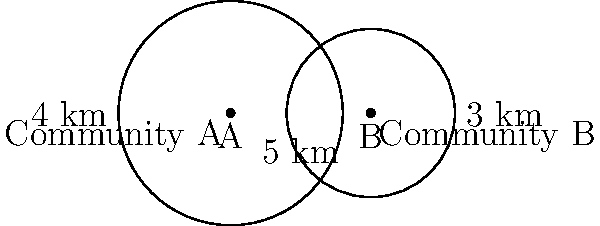Two circular regions represent HIV treatment coverage areas for two different communities. Community A's coverage has a radius of 4 km, while Community B's coverage has a radius of 3 km. The centers of these circles are 5 km apart. Calculate the area of the overlapping region where both communities provide HIV treatment coverage. Round your answer to the nearest square kilometer. To find the area of overlap between two circles, we can use the following steps:

1) First, we need to determine if the circles intersect. They do if the distance between their centers is less than the sum of their radii:
   $5 < 4 + 3 = 7$, so they do intersect.

2) Next, we calculate the distance from each circle's center to the chord of intersection:
   For circle A: $a = \frac{4^2 - 3^2 + 5^2}{2(5)} = 2.9$ km
   For circle B: $b = 5 - 2.9 = 2.1$ km

3) We then find the central angle for each circle:
   For circle A: $\theta_A = 2 \arccos(\frac{2.9}{4}) = 2.2143$ radians
   For circle B: $\theta_B = 2 \arccos(\frac{2.1}{3}) = 2.7127$ radians

4) Now we can calculate the area of each sector:
   Sector A: $\frac{1}{2} \cdot 4^2 \cdot 2.2143 = 8.8572$ km²
   Sector B: $\frac{1}{2} \cdot 3^2 \cdot 2.7127 = 12.2071$ km²

5) We also need to calculate the area of each triangle:
   Triangle A: $\frac{1}{2} \cdot 4 \cdot 2.9 \cdot \sin(2.2143/2) = 5.4101$ km²
   Triangle B: $\frac{1}{2} \cdot 3 \cdot 2.1 \cdot \sin(2.7127/2) = 3.0321$ km²

6) The area of overlap is the sum of the sectors minus the sum of the triangles:
   Overlap = $(8.8572 + 12.2071) - (5.4101 + 3.0321) = 12.6221$ km²

7) Rounding to the nearest square kilometer gives us 13 km².
Answer: 13 km² 